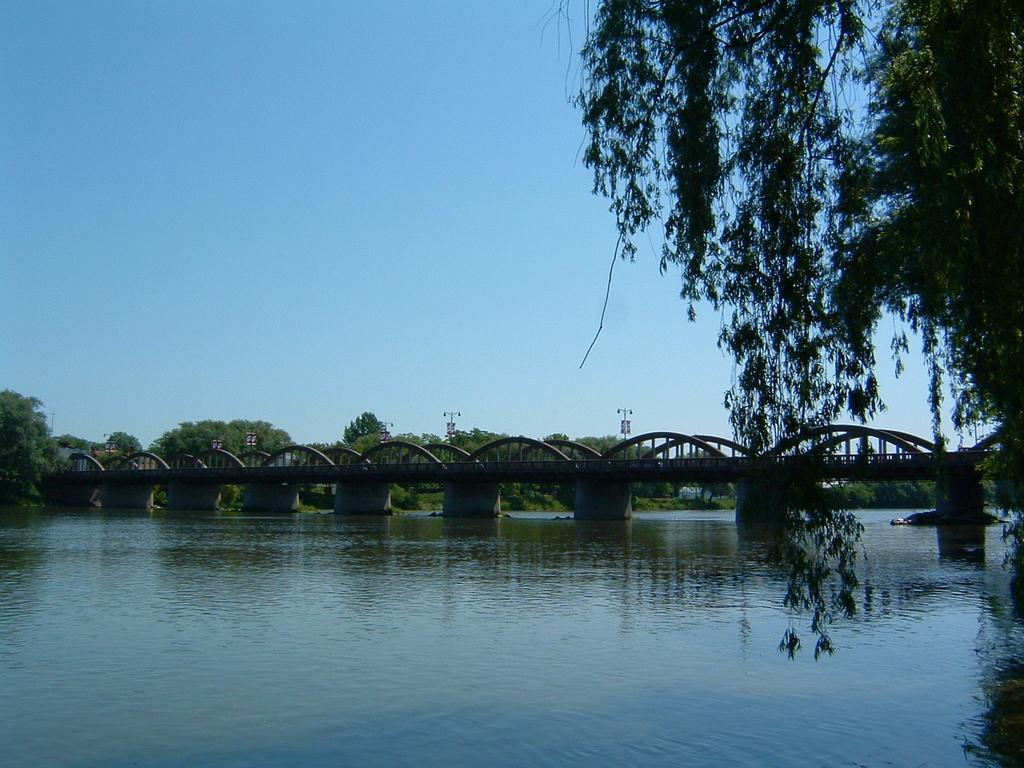What body of water is present in the image? There is a lake in the image. Where is the tree located in the image? The tree is on the right side of the image. What structure can be seen in the background of the image? There is a bridge in the background of the image. What type of vegetation is visible in the background of the image? There are trees visible in the background of the image. What color is the sky in the image? The sky is blue in the image. Can you read the note that is floating on the lake in the image? There is no note present in the image; it only features a lake, a tree, a bridge, and trees in the background. 